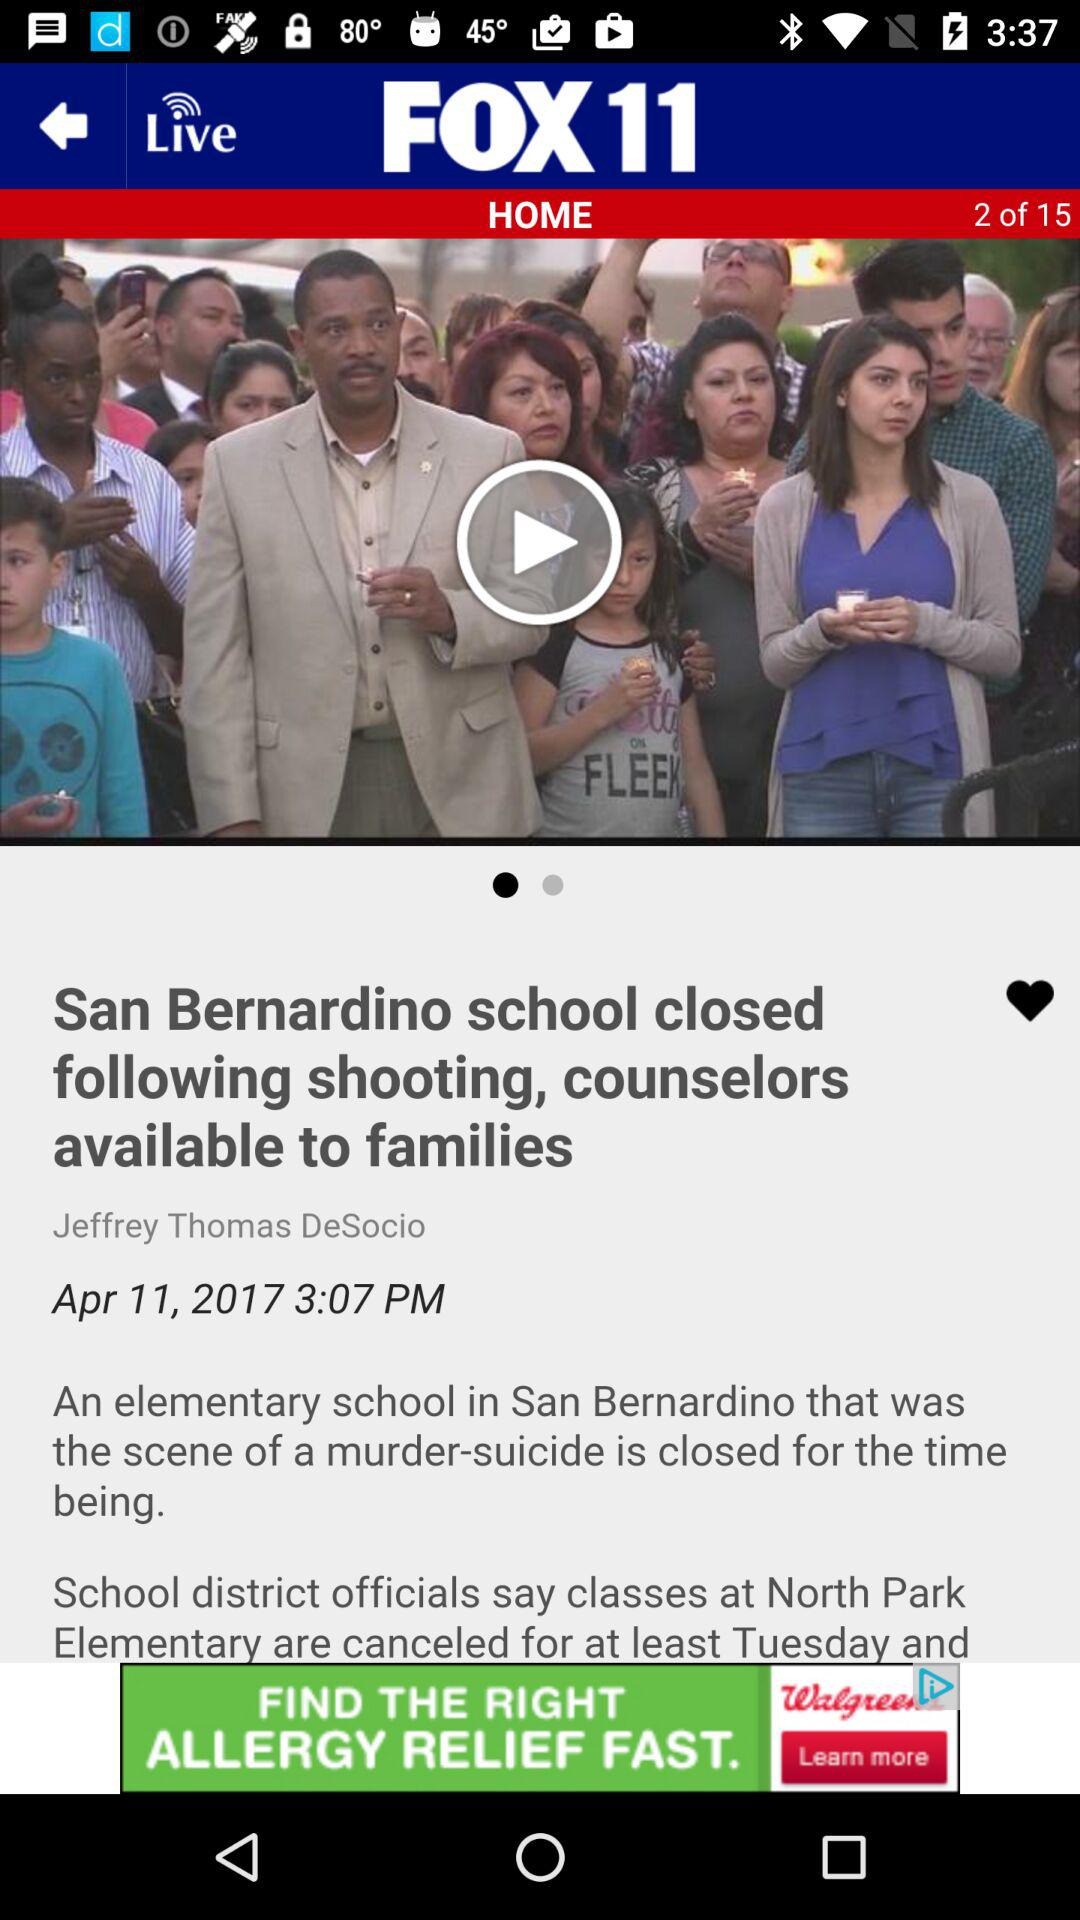Who is the author? The author is Jeffrey Thomas DeSocio. 